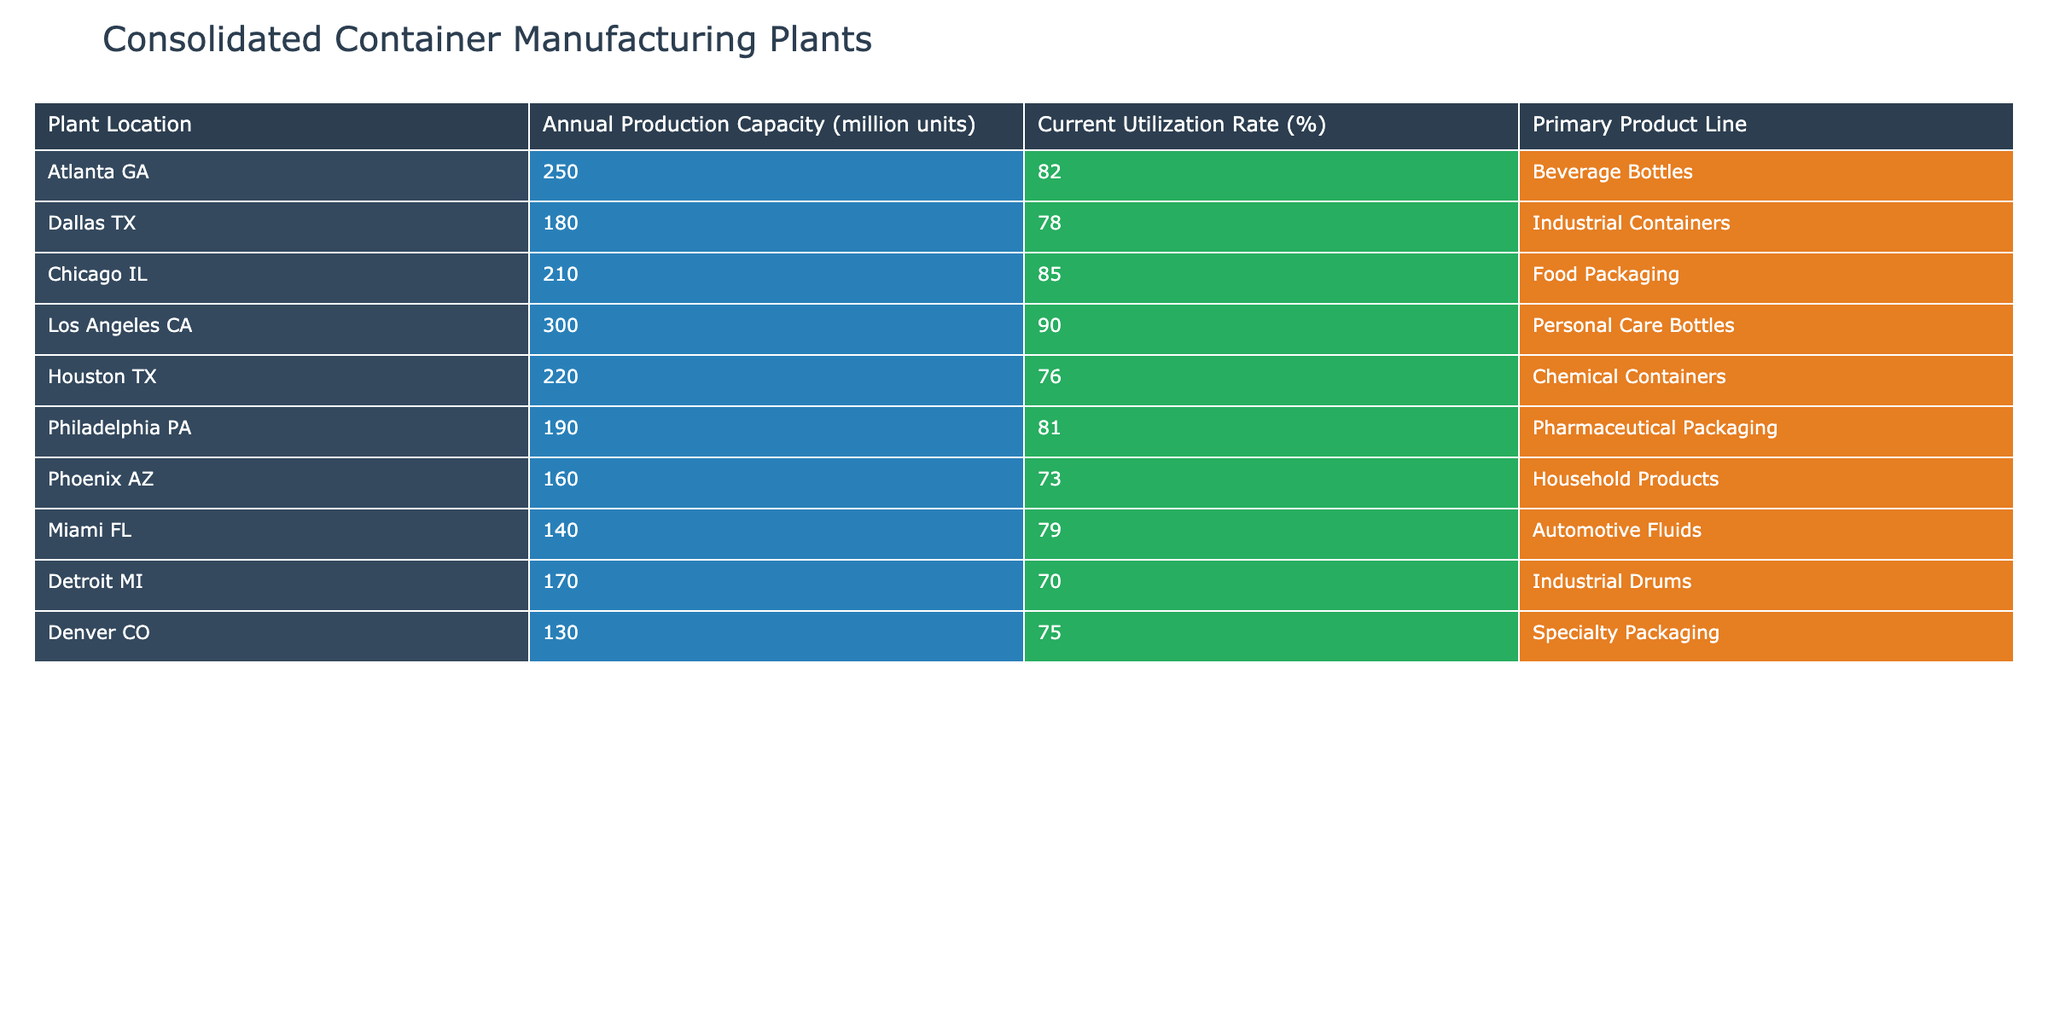What is the annual production capacity of the Los Angeles plant? The table shows that the annual production capacity for the Los Angeles plant is listed under the "Annual Production Capacity" column for that location. It states 300 million units.
Answer: 300 million units Which plant has the highest current utilization rate? By checking the "Current Utilization Rate" column in the table, the highest value is 90%, corresponding to the Los Angeles plant.
Answer: Los Angeles CA What is the average annual production capacity of all plants? To find the average, sum the annual production capacities (250 + 180 + 210 + 300 + 220 + 190 + 160 + 140 + 170 + 130 = 1850) and divide by the number of plants (10). The average is 1850 / 10 = 185 million units.
Answer: 185 million units Is the utilization rate of the Chicago plant above 80%? The table indicates the utilization rate for Chicago is 85%, which is greater than 80%.
Answer: Yes What is the difference in annual production capacity between the Atlanta and Dallas plants? The Atlanta plant has an annual capacity of 250 million units and the Dallas plant has 180 million units. The difference is calculated as 250 - 180 = 70 million units.
Answer: 70 million units Which plant produces Pharmaceutical Packaging, and what is its utilization rate? The table shows that the Philadelphia plant produces Pharmaceutical Packaging, and its utilization rate is listed as 81%.
Answer: Philadelphia PA, 81% If you combine the production capacities of the Houston and Miami plants, what is the total? The annual production capacity for Houston is 220 million units and for Miami is 140 million units. Adding these gives 220 + 140 = 360 million units.
Answer: 360 million units Is it true that the Detroit plant has a utilization rate lower than 75%? By looking at the utilization rate listed for the Detroit plant, which is 70%, it is indeed lower than 75%.
Answer: Yes Which plant has a primary product line of Household Products, and what is its annual production capacity? The table identifies the Phoenix plant as having Household Products as the primary product line, with an annual production capacity of 160 million units.
Answer: Phoenix AZ, 160 million units What is the total annual production capacity of the plants that produce Industrial Containers and Chemical Containers? Dallas produces Industrial Containers at 180 million units, and Houston produces Chemical Containers at 220 million units. Adding these together gives 180 + 220 = 400 million units.
Answer: 400 million units 